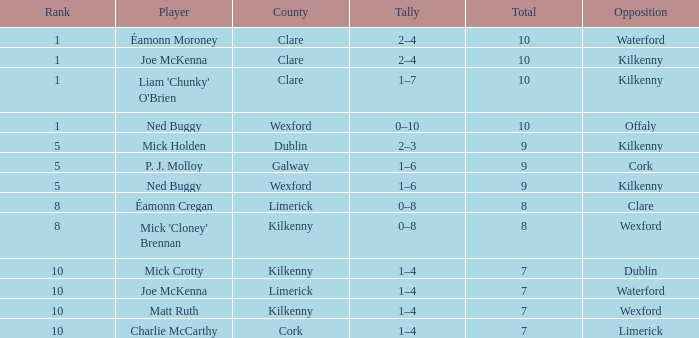Which county features joe mckenna as a player with a rank exceeding 8? Limerick. 